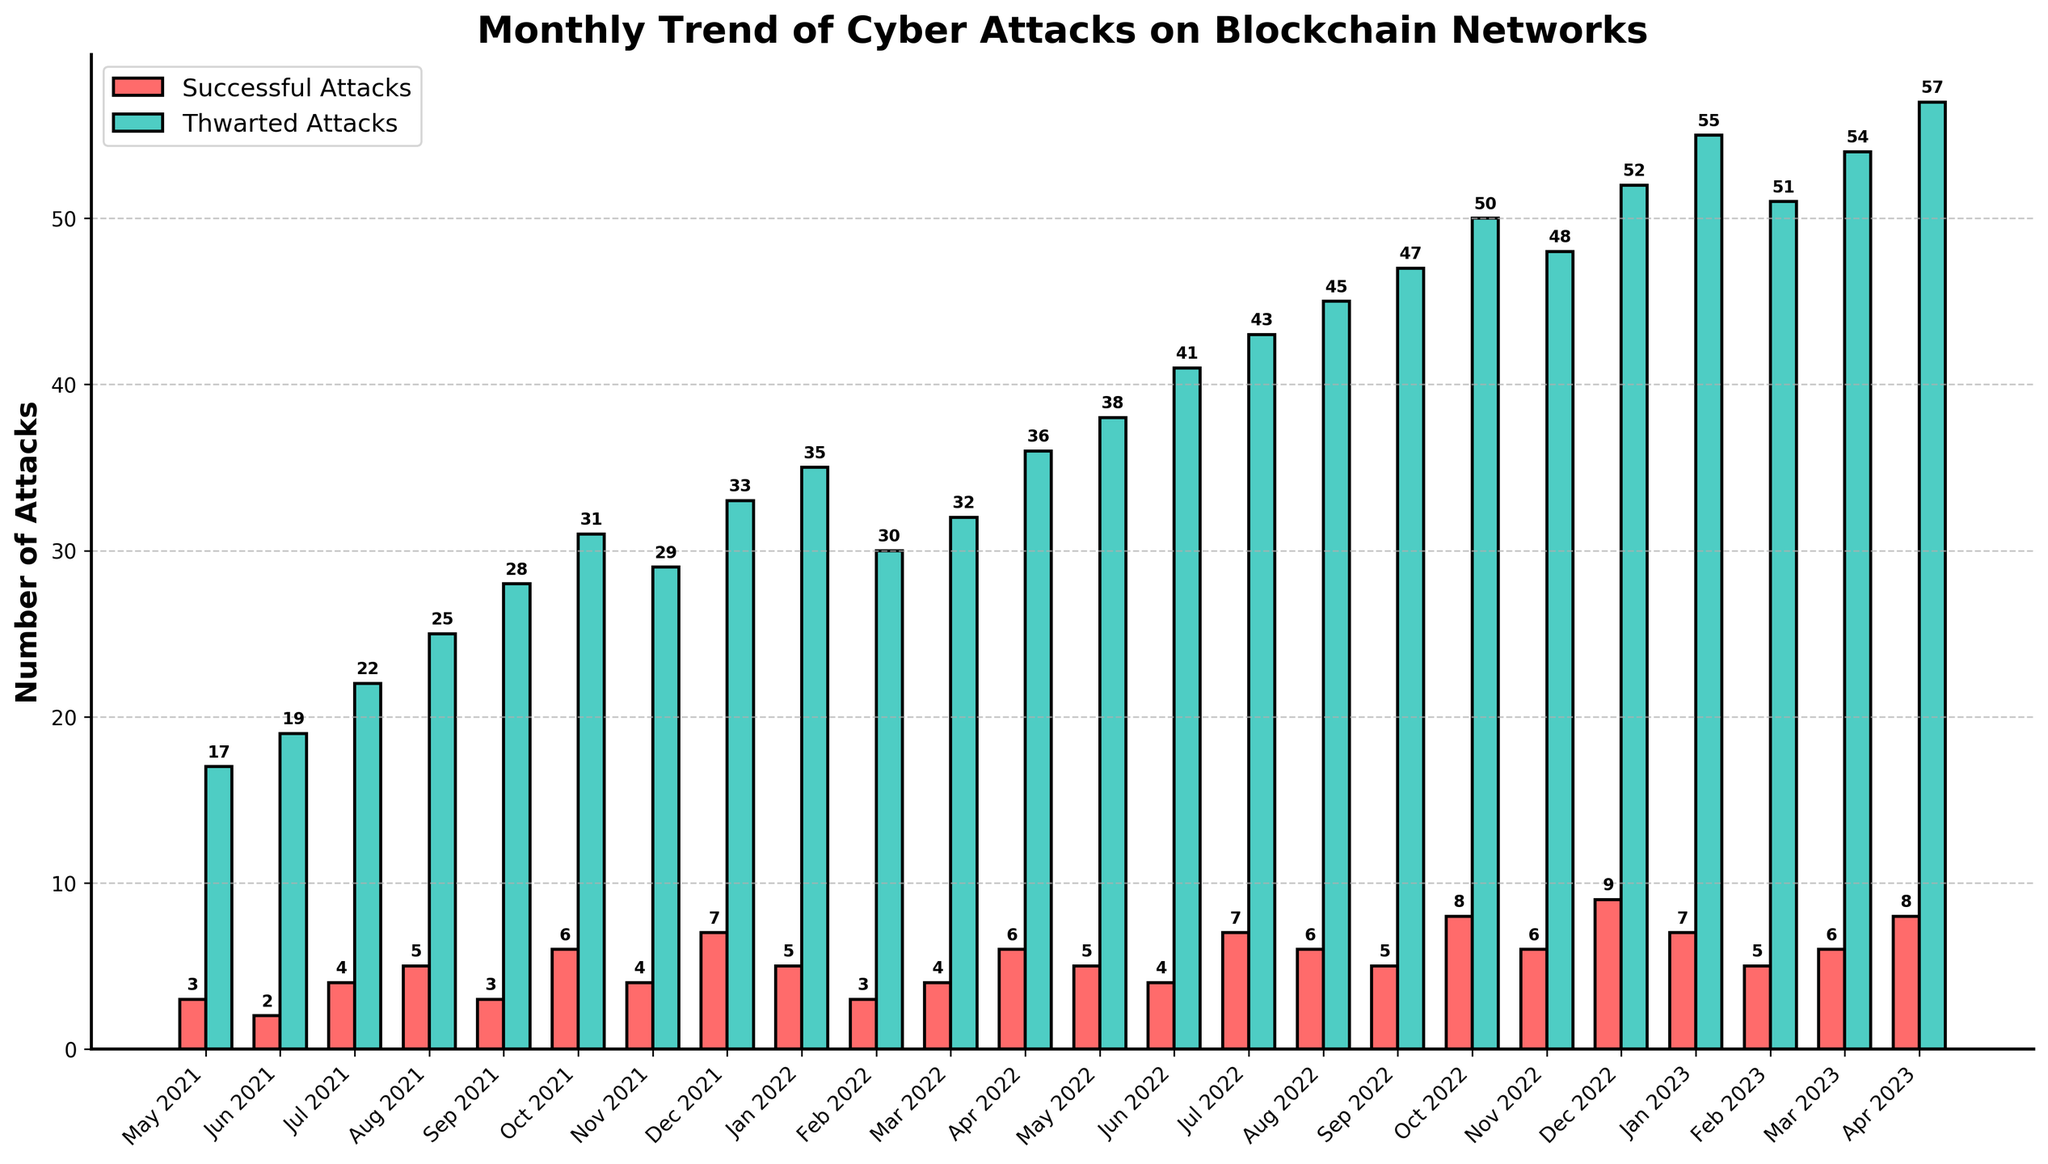What is the number of successful attacks in Oct 2022? In Oct 2022, the red bar corresponding to successful attacks has a height of 8, indicating that there were 8 successful attacks during that month.
Answer: 8 How many more thwarted attacks were there than successful attacks in May 2022? In May 2022, the number of thwarted attacks is 38, and the number of successful attacks is 5. The difference is 38 - 5 = 33.
Answer: 33 Which month had the highest number of thwarted attacks? The highest green bar corresponds to Apr 2023, indicating that Apr 2023 had the highest number of thwarted attacks, which is 57.
Answer: Apr 2023 What is the average number of successful attacks from May 2021 to Apr 2023? Sum all successful attacks: 3 + 2 + 4 + 5 + 3 + 6 + 4 + 7 + 5 + 3 + 4 + 6 + 5 + 4 + 7 + 6 + 5 + 8 + 6 + 9 + 7 + 5 + 6 + 8 = 129. There are 24 months, so the average is 129 / 24 ≈ 5.38.
Answer: 5.38 In which month did the number of successful attacks exceed the number of thwarted attacks by the largest margin? By observing the largest difference where successful attacks (red bars) exceed thwarted attacks (green bars), it never happens in the data provided. Therefore, there is no month where successful attacks exceed thwarted attacks.
Answer: None Which month experienced the largest number of successful attacks? The tallest red bar corresponds to Dec 2022, indicating that Dec 2022 had the most successful attacks, which is 9.
Answer: Dec 2022 What is the ratio of thwarted attacks to successful attacks in Apr 2022? In Apr 2022, there are 36 thwarted attacks and 6 successful attacks. The ratio is 36 / 6 = 6.
Answer: 6:1 Did the number of successful attacks ever reach double digits in any month? By observing the height of the red bars, none of them exceeds 9, indicating successful attacks never reached double digits.
Answer: No 